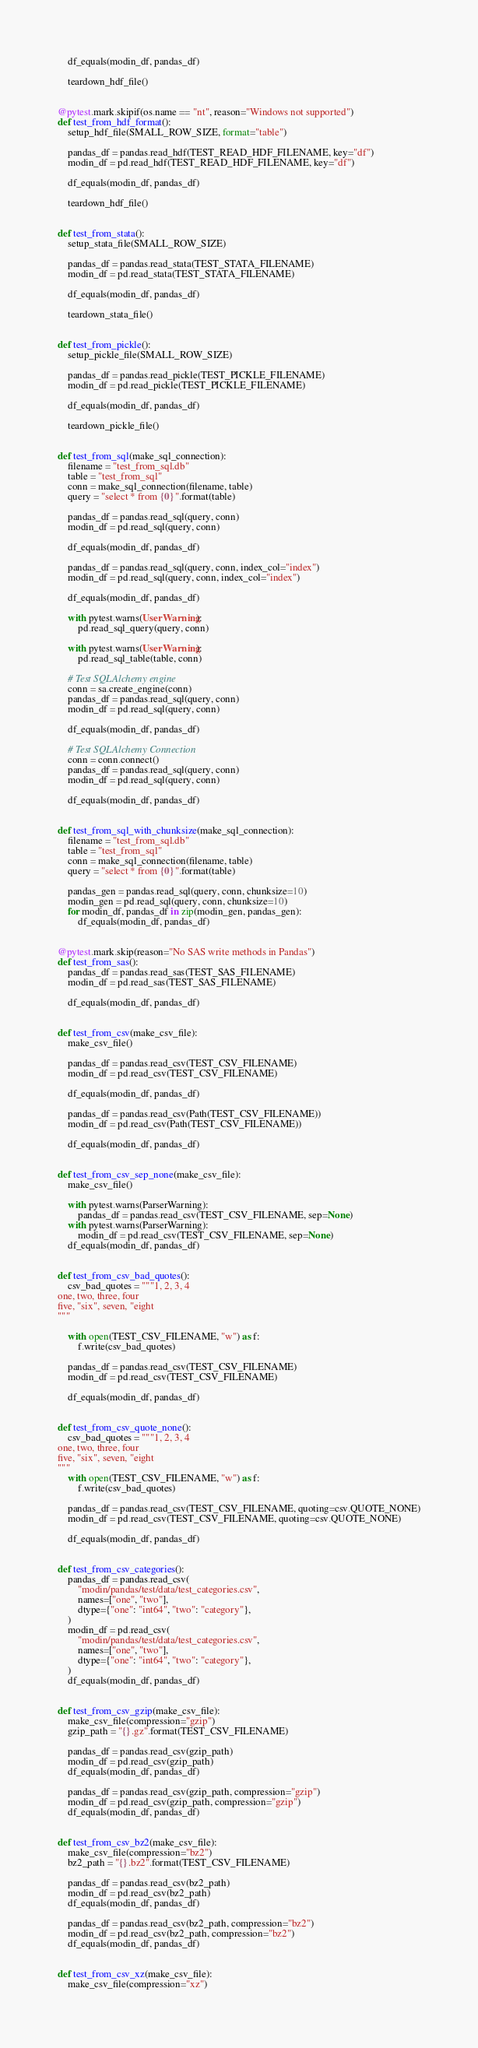Convert code to text. <code><loc_0><loc_0><loc_500><loc_500><_Python_>
    df_equals(modin_df, pandas_df)

    teardown_hdf_file()


@pytest.mark.skipif(os.name == "nt", reason="Windows not supported")
def test_from_hdf_format():
    setup_hdf_file(SMALL_ROW_SIZE, format="table")

    pandas_df = pandas.read_hdf(TEST_READ_HDF_FILENAME, key="df")
    modin_df = pd.read_hdf(TEST_READ_HDF_FILENAME, key="df")

    df_equals(modin_df, pandas_df)

    teardown_hdf_file()


def test_from_stata():
    setup_stata_file(SMALL_ROW_SIZE)

    pandas_df = pandas.read_stata(TEST_STATA_FILENAME)
    modin_df = pd.read_stata(TEST_STATA_FILENAME)

    df_equals(modin_df, pandas_df)

    teardown_stata_file()


def test_from_pickle():
    setup_pickle_file(SMALL_ROW_SIZE)

    pandas_df = pandas.read_pickle(TEST_PICKLE_FILENAME)
    modin_df = pd.read_pickle(TEST_PICKLE_FILENAME)

    df_equals(modin_df, pandas_df)

    teardown_pickle_file()


def test_from_sql(make_sql_connection):
    filename = "test_from_sql.db"
    table = "test_from_sql"
    conn = make_sql_connection(filename, table)
    query = "select * from {0}".format(table)

    pandas_df = pandas.read_sql(query, conn)
    modin_df = pd.read_sql(query, conn)

    df_equals(modin_df, pandas_df)

    pandas_df = pandas.read_sql(query, conn, index_col="index")
    modin_df = pd.read_sql(query, conn, index_col="index")

    df_equals(modin_df, pandas_df)

    with pytest.warns(UserWarning):
        pd.read_sql_query(query, conn)

    with pytest.warns(UserWarning):
        pd.read_sql_table(table, conn)

    # Test SQLAlchemy engine
    conn = sa.create_engine(conn)
    pandas_df = pandas.read_sql(query, conn)
    modin_df = pd.read_sql(query, conn)

    df_equals(modin_df, pandas_df)

    # Test SQLAlchemy Connection
    conn = conn.connect()
    pandas_df = pandas.read_sql(query, conn)
    modin_df = pd.read_sql(query, conn)

    df_equals(modin_df, pandas_df)


def test_from_sql_with_chunksize(make_sql_connection):
    filename = "test_from_sql.db"
    table = "test_from_sql"
    conn = make_sql_connection(filename, table)
    query = "select * from {0}".format(table)

    pandas_gen = pandas.read_sql(query, conn, chunksize=10)
    modin_gen = pd.read_sql(query, conn, chunksize=10)
    for modin_df, pandas_df in zip(modin_gen, pandas_gen):
        df_equals(modin_df, pandas_df)


@pytest.mark.skip(reason="No SAS write methods in Pandas")
def test_from_sas():
    pandas_df = pandas.read_sas(TEST_SAS_FILENAME)
    modin_df = pd.read_sas(TEST_SAS_FILENAME)

    df_equals(modin_df, pandas_df)


def test_from_csv(make_csv_file):
    make_csv_file()

    pandas_df = pandas.read_csv(TEST_CSV_FILENAME)
    modin_df = pd.read_csv(TEST_CSV_FILENAME)

    df_equals(modin_df, pandas_df)

    pandas_df = pandas.read_csv(Path(TEST_CSV_FILENAME))
    modin_df = pd.read_csv(Path(TEST_CSV_FILENAME))

    df_equals(modin_df, pandas_df)


def test_from_csv_sep_none(make_csv_file):
    make_csv_file()

    with pytest.warns(ParserWarning):
        pandas_df = pandas.read_csv(TEST_CSV_FILENAME, sep=None)
    with pytest.warns(ParserWarning):
        modin_df = pd.read_csv(TEST_CSV_FILENAME, sep=None)
    df_equals(modin_df, pandas_df)


def test_from_csv_bad_quotes():
    csv_bad_quotes = """1, 2, 3, 4
one, two, three, four
five, "six", seven, "eight
"""

    with open(TEST_CSV_FILENAME, "w") as f:
        f.write(csv_bad_quotes)

    pandas_df = pandas.read_csv(TEST_CSV_FILENAME)
    modin_df = pd.read_csv(TEST_CSV_FILENAME)

    df_equals(modin_df, pandas_df)


def test_from_csv_quote_none():
    csv_bad_quotes = """1, 2, 3, 4
one, two, three, four
five, "six", seven, "eight
"""
    with open(TEST_CSV_FILENAME, "w") as f:
        f.write(csv_bad_quotes)

    pandas_df = pandas.read_csv(TEST_CSV_FILENAME, quoting=csv.QUOTE_NONE)
    modin_df = pd.read_csv(TEST_CSV_FILENAME, quoting=csv.QUOTE_NONE)

    df_equals(modin_df, pandas_df)


def test_from_csv_categories():
    pandas_df = pandas.read_csv(
        "modin/pandas/test/data/test_categories.csv",
        names=["one", "two"],
        dtype={"one": "int64", "two": "category"},
    )
    modin_df = pd.read_csv(
        "modin/pandas/test/data/test_categories.csv",
        names=["one", "two"],
        dtype={"one": "int64", "two": "category"},
    )
    df_equals(modin_df, pandas_df)


def test_from_csv_gzip(make_csv_file):
    make_csv_file(compression="gzip")
    gzip_path = "{}.gz".format(TEST_CSV_FILENAME)

    pandas_df = pandas.read_csv(gzip_path)
    modin_df = pd.read_csv(gzip_path)
    df_equals(modin_df, pandas_df)

    pandas_df = pandas.read_csv(gzip_path, compression="gzip")
    modin_df = pd.read_csv(gzip_path, compression="gzip")
    df_equals(modin_df, pandas_df)


def test_from_csv_bz2(make_csv_file):
    make_csv_file(compression="bz2")
    bz2_path = "{}.bz2".format(TEST_CSV_FILENAME)

    pandas_df = pandas.read_csv(bz2_path)
    modin_df = pd.read_csv(bz2_path)
    df_equals(modin_df, pandas_df)

    pandas_df = pandas.read_csv(bz2_path, compression="bz2")
    modin_df = pd.read_csv(bz2_path, compression="bz2")
    df_equals(modin_df, pandas_df)


def test_from_csv_xz(make_csv_file):
    make_csv_file(compression="xz")</code> 